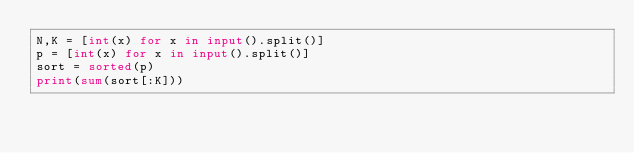<code> <loc_0><loc_0><loc_500><loc_500><_Python_>N,K = [int(x) for x in input().split()]
p = [int(x) for x in input().split()]
sort = sorted(p)
print(sum(sort[:K]))</code> 